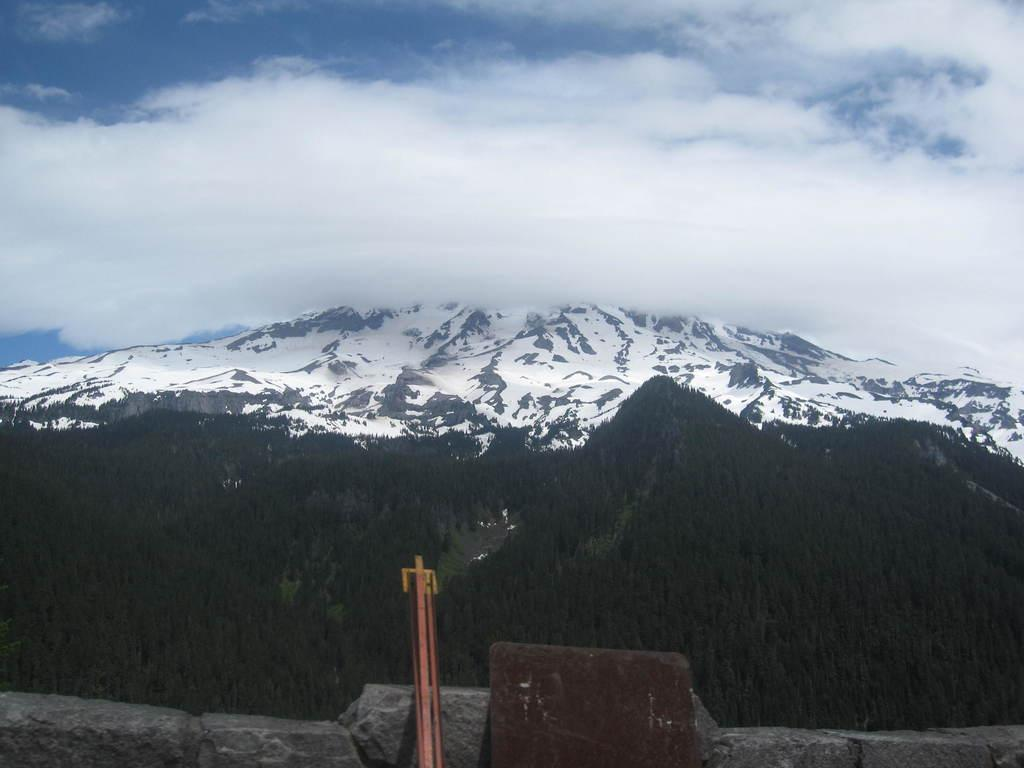What is visible at the top of the image? The sky is visible at the top of the image. What geographical features can be seen in the middle of the image? There is a hill and a valley in the middle of the image. What type of terrain is present at the bottom of the image? Stones are present at the bottom of the image. Can you describe any other objects visible in the image? There are other objects visible in the image, but their specific nature is not mentioned in the provided facts. How many beds are visible in the image? There are no beds present in the image. What type of division can be seen between the hill and the valley in the image? The provided facts do not mention any specific division between the hill and the valley in the image. 